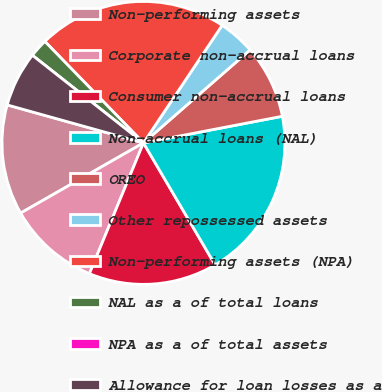<chart> <loc_0><loc_0><loc_500><loc_500><pie_chart><fcel>Non-performing assets<fcel>Corporate non-accrual loans<fcel>Consumer non-accrual loans<fcel>Non-accrual loans (NAL)<fcel>OREO<fcel>Other repossessed assets<fcel>Non-performing assets (NPA)<fcel>NAL as a of total loans<fcel>NPA as a of total assets<fcel>Allowance for loan losses as a<nl><fcel>12.59%<fcel>10.5%<fcel>14.69%<fcel>19.56%<fcel>8.4%<fcel>4.2%<fcel>21.66%<fcel>2.1%<fcel>0.0%<fcel>6.3%<nl></chart> 